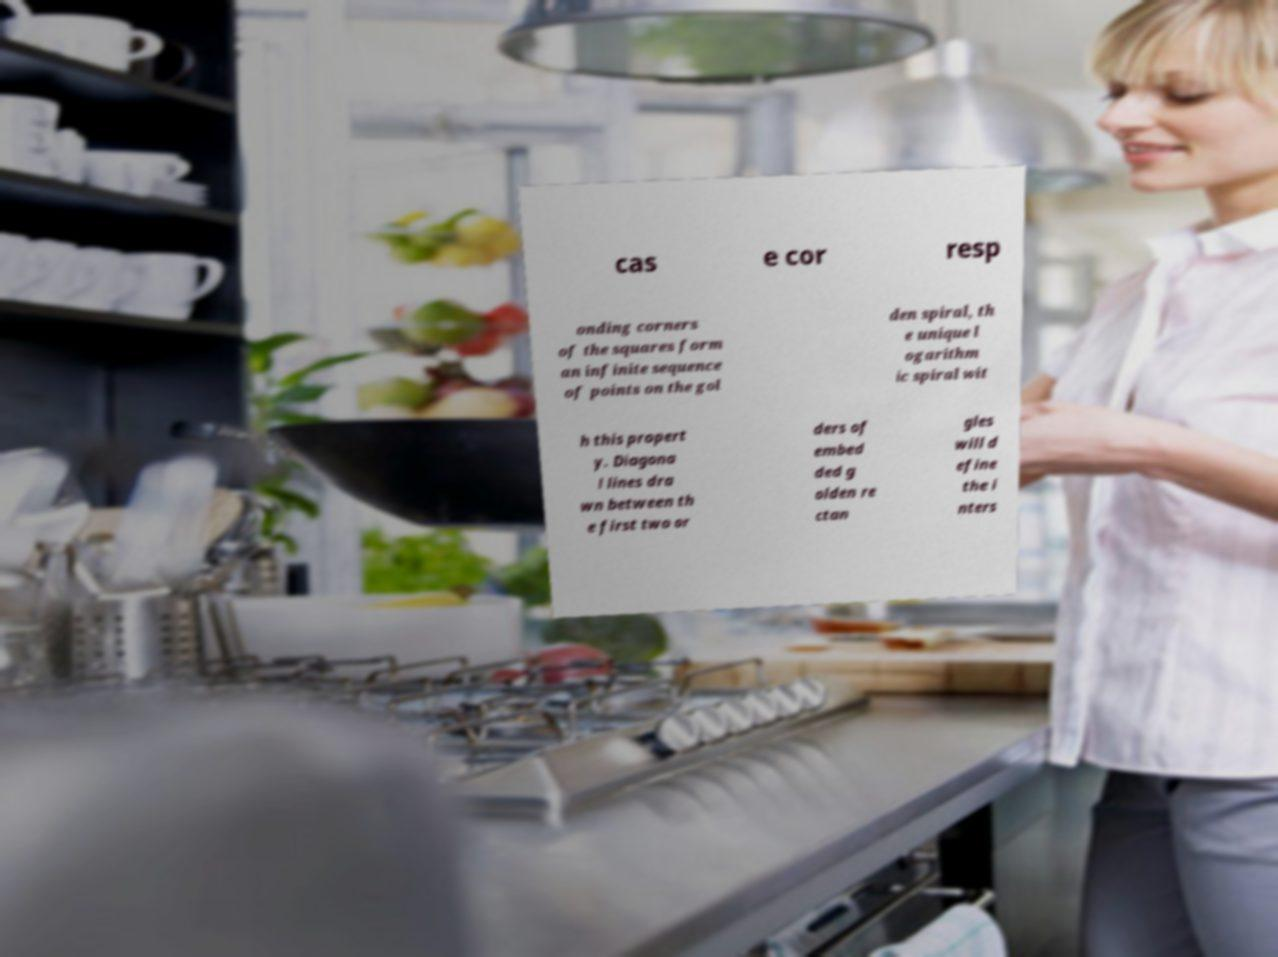Could you extract and type out the text from this image? cas e cor resp onding corners of the squares form an infinite sequence of points on the gol den spiral, th e unique l ogarithm ic spiral wit h this propert y. Diagona l lines dra wn between th e first two or ders of embed ded g olden re ctan gles will d efine the i nters 